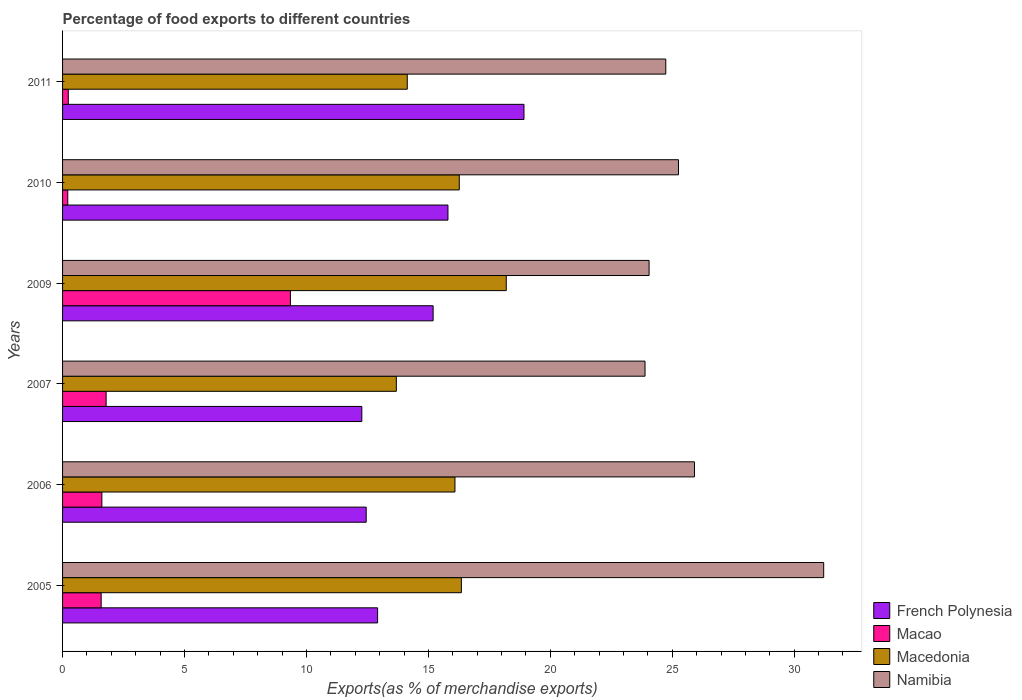Are the number of bars on each tick of the Y-axis equal?
Your response must be concise. Yes. How many bars are there on the 5th tick from the top?
Provide a short and direct response. 4. What is the percentage of exports to different countries in French Polynesia in 2010?
Your answer should be very brief. 15.8. Across all years, what is the maximum percentage of exports to different countries in French Polynesia?
Offer a terse response. 18.92. Across all years, what is the minimum percentage of exports to different countries in Macao?
Give a very brief answer. 0.21. In which year was the percentage of exports to different countries in Macao maximum?
Your response must be concise. 2009. In which year was the percentage of exports to different countries in Namibia minimum?
Make the answer very short. 2007. What is the total percentage of exports to different countries in Macao in the graph?
Your response must be concise. 14.77. What is the difference between the percentage of exports to different countries in Macedonia in 2009 and that in 2011?
Your answer should be very brief. 4.06. What is the difference between the percentage of exports to different countries in Namibia in 2005 and the percentage of exports to different countries in French Polynesia in 2007?
Provide a succinct answer. 18.94. What is the average percentage of exports to different countries in Macedonia per year?
Offer a terse response. 15.79. In the year 2006, what is the difference between the percentage of exports to different countries in Macedonia and percentage of exports to different countries in French Polynesia?
Your answer should be compact. 3.64. In how many years, is the percentage of exports to different countries in Macao greater than 31 %?
Ensure brevity in your answer.  0. What is the ratio of the percentage of exports to different countries in Macao in 2009 to that in 2010?
Give a very brief answer. 43.85. Is the difference between the percentage of exports to different countries in Macedonia in 2007 and 2011 greater than the difference between the percentage of exports to different countries in French Polynesia in 2007 and 2011?
Offer a very short reply. Yes. What is the difference between the highest and the second highest percentage of exports to different countries in Macedonia?
Keep it short and to the point. 1.84. What is the difference between the highest and the lowest percentage of exports to different countries in Macedonia?
Make the answer very short. 4.51. What does the 4th bar from the top in 2005 represents?
Your answer should be compact. French Polynesia. What does the 1st bar from the bottom in 2006 represents?
Offer a very short reply. French Polynesia. How many bars are there?
Your answer should be compact. 24. How many years are there in the graph?
Give a very brief answer. 6. Does the graph contain any zero values?
Keep it short and to the point. No. Does the graph contain grids?
Give a very brief answer. No. Where does the legend appear in the graph?
Your answer should be very brief. Bottom right. What is the title of the graph?
Ensure brevity in your answer.  Percentage of food exports to different countries. Does "Libya" appear as one of the legend labels in the graph?
Your response must be concise. No. What is the label or title of the X-axis?
Your answer should be very brief. Exports(as % of merchandise exports). What is the Exports(as % of merchandise exports) in French Polynesia in 2005?
Ensure brevity in your answer.  12.92. What is the Exports(as % of merchandise exports) in Macao in 2005?
Your answer should be compact. 1.58. What is the Exports(as % of merchandise exports) of Macedonia in 2005?
Your response must be concise. 16.35. What is the Exports(as % of merchandise exports) of Namibia in 2005?
Ensure brevity in your answer.  31.21. What is the Exports(as % of merchandise exports) in French Polynesia in 2006?
Your response must be concise. 12.45. What is the Exports(as % of merchandise exports) in Macao in 2006?
Your response must be concise. 1.61. What is the Exports(as % of merchandise exports) of Macedonia in 2006?
Give a very brief answer. 16.09. What is the Exports(as % of merchandise exports) of Namibia in 2006?
Your answer should be very brief. 25.91. What is the Exports(as % of merchandise exports) of French Polynesia in 2007?
Offer a terse response. 12.27. What is the Exports(as % of merchandise exports) in Macao in 2007?
Provide a short and direct response. 1.79. What is the Exports(as % of merchandise exports) of Macedonia in 2007?
Your answer should be very brief. 13.69. What is the Exports(as % of merchandise exports) in Namibia in 2007?
Keep it short and to the point. 23.88. What is the Exports(as % of merchandise exports) of French Polynesia in 2009?
Give a very brief answer. 15.19. What is the Exports(as % of merchandise exports) of Macao in 2009?
Your answer should be very brief. 9.34. What is the Exports(as % of merchandise exports) in Macedonia in 2009?
Keep it short and to the point. 18.19. What is the Exports(as % of merchandise exports) in Namibia in 2009?
Your answer should be very brief. 24.05. What is the Exports(as % of merchandise exports) in French Polynesia in 2010?
Provide a short and direct response. 15.8. What is the Exports(as % of merchandise exports) in Macao in 2010?
Ensure brevity in your answer.  0.21. What is the Exports(as % of merchandise exports) in Macedonia in 2010?
Your response must be concise. 16.27. What is the Exports(as % of merchandise exports) in Namibia in 2010?
Give a very brief answer. 25.25. What is the Exports(as % of merchandise exports) of French Polynesia in 2011?
Your answer should be compact. 18.92. What is the Exports(as % of merchandise exports) in Macao in 2011?
Offer a very short reply. 0.24. What is the Exports(as % of merchandise exports) in Macedonia in 2011?
Ensure brevity in your answer.  14.13. What is the Exports(as % of merchandise exports) of Namibia in 2011?
Your answer should be compact. 24.73. Across all years, what is the maximum Exports(as % of merchandise exports) in French Polynesia?
Offer a very short reply. 18.92. Across all years, what is the maximum Exports(as % of merchandise exports) in Macao?
Your answer should be compact. 9.34. Across all years, what is the maximum Exports(as % of merchandise exports) of Macedonia?
Provide a succinct answer. 18.19. Across all years, what is the maximum Exports(as % of merchandise exports) in Namibia?
Give a very brief answer. 31.21. Across all years, what is the minimum Exports(as % of merchandise exports) in French Polynesia?
Provide a succinct answer. 12.27. Across all years, what is the minimum Exports(as % of merchandise exports) of Macao?
Ensure brevity in your answer.  0.21. Across all years, what is the minimum Exports(as % of merchandise exports) of Macedonia?
Keep it short and to the point. 13.69. Across all years, what is the minimum Exports(as % of merchandise exports) in Namibia?
Your answer should be very brief. 23.88. What is the total Exports(as % of merchandise exports) of French Polynesia in the graph?
Your answer should be compact. 87.55. What is the total Exports(as % of merchandise exports) in Macao in the graph?
Your answer should be very brief. 14.77. What is the total Exports(as % of merchandise exports) of Macedonia in the graph?
Your answer should be compact. 94.72. What is the total Exports(as % of merchandise exports) in Namibia in the graph?
Your response must be concise. 155.04. What is the difference between the Exports(as % of merchandise exports) in French Polynesia in 2005 and that in 2006?
Your answer should be very brief. 0.47. What is the difference between the Exports(as % of merchandise exports) in Macao in 2005 and that in 2006?
Offer a terse response. -0.03. What is the difference between the Exports(as % of merchandise exports) in Macedonia in 2005 and that in 2006?
Your response must be concise. 0.26. What is the difference between the Exports(as % of merchandise exports) of Namibia in 2005 and that in 2006?
Offer a very short reply. 5.3. What is the difference between the Exports(as % of merchandise exports) in French Polynesia in 2005 and that in 2007?
Provide a short and direct response. 0.65. What is the difference between the Exports(as % of merchandise exports) in Macao in 2005 and that in 2007?
Make the answer very short. -0.2. What is the difference between the Exports(as % of merchandise exports) in Macedonia in 2005 and that in 2007?
Your answer should be compact. 2.67. What is the difference between the Exports(as % of merchandise exports) in Namibia in 2005 and that in 2007?
Your answer should be compact. 7.33. What is the difference between the Exports(as % of merchandise exports) in French Polynesia in 2005 and that in 2009?
Your answer should be compact. -2.28. What is the difference between the Exports(as % of merchandise exports) in Macao in 2005 and that in 2009?
Provide a short and direct response. -7.76. What is the difference between the Exports(as % of merchandise exports) in Macedonia in 2005 and that in 2009?
Keep it short and to the point. -1.84. What is the difference between the Exports(as % of merchandise exports) in Namibia in 2005 and that in 2009?
Offer a very short reply. 7.16. What is the difference between the Exports(as % of merchandise exports) of French Polynesia in 2005 and that in 2010?
Make the answer very short. -2.88. What is the difference between the Exports(as % of merchandise exports) in Macao in 2005 and that in 2010?
Your answer should be compact. 1.37. What is the difference between the Exports(as % of merchandise exports) of Macedonia in 2005 and that in 2010?
Keep it short and to the point. 0.09. What is the difference between the Exports(as % of merchandise exports) in Namibia in 2005 and that in 2010?
Your response must be concise. 5.95. What is the difference between the Exports(as % of merchandise exports) in French Polynesia in 2005 and that in 2011?
Offer a very short reply. -6. What is the difference between the Exports(as % of merchandise exports) in Macao in 2005 and that in 2011?
Your answer should be very brief. 1.35. What is the difference between the Exports(as % of merchandise exports) of Macedonia in 2005 and that in 2011?
Your answer should be compact. 2.22. What is the difference between the Exports(as % of merchandise exports) in Namibia in 2005 and that in 2011?
Make the answer very short. 6.47. What is the difference between the Exports(as % of merchandise exports) in French Polynesia in 2006 and that in 2007?
Your answer should be very brief. 0.18. What is the difference between the Exports(as % of merchandise exports) of Macao in 2006 and that in 2007?
Your response must be concise. -0.17. What is the difference between the Exports(as % of merchandise exports) of Macedonia in 2006 and that in 2007?
Provide a short and direct response. 2.4. What is the difference between the Exports(as % of merchandise exports) of Namibia in 2006 and that in 2007?
Offer a very short reply. 2.03. What is the difference between the Exports(as % of merchandise exports) in French Polynesia in 2006 and that in 2009?
Make the answer very short. -2.75. What is the difference between the Exports(as % of merchandise exports) of Macao in 2006 and that in 2009?
Give a very brief answer. -7.73. What is the difference between the Exports(as % of merchandise exports) of Macedonia in 2006 and that in 2009?
Make the answer very short. -2.1. What is the difference between the Exports(as % of merchandise exports) of Namibia in 2006 and that in 2009?
Provide a short and direct response. 1.86. What is the difference between the Exports(as % of merchandise exports) in French Polynesia in 2006 and that in 2010?
Keep it short and to the point. -3.35. What is the difference between the Exports(as % of merchandise exports) in Macao in 2006 and that in 2010?
Keep it short and to the point. 1.4. What is the difference between the Exports(as % of merchandise exports) in Macedonia in 2006 and that in 2010?
Make the answer very short. -0.18. What is the difference between the Exports(as % of merchandise exports) in Namibia in 2006 and that in 2010?
Ensure brevity in your answer.  0.66. What is the difference between the Exports(as % of merchandise exports) of French Polynesia in 2006 and that in 2011?
Offer a terse response. -6.47. What is the difference between the Exports(as % of merchandise exports) in Macao in 2006 and that in 2011?
Provide a succinct answer. 1.38. What is the difference between the Exports(as % of merchandise exports) of Macedonia in 2006 and that in 2011?
Make the answer very short. 1.96. What is the difference between the Exports(as % of merchandise exports) of Namibia in 2006 and that in 2011?
Your response must be concise. 1.18. What is the difference between the Exports(as % of merchandise exports) in French Polynesia in 2007 and that in 2009?
Ensure brevity in your answer.  -2.92. What is the difference between the Exports(as % of merchandise exports) in Macao in 2007 and that in 2009?
Provide a short and direct response. -7.56. What is the difference between the Exports(as % of merchandise exports) of Macedonia in 2007 and that in 2009?
Provide a short and direct response. -4.51. What is the difference between the Exports(as % of merchandise exports) in Namibia in 2007 and that in 2009?
Your answer should be compact. -0.17. What is the difference between the Exports(as % of merchandise exports) in French Polynesia in 2007 and that in 2010?
Keep it short and to the point. -3.53. What is the difference between the Exports(as % of merchandise exports) in Macao in 2007 and that in 2010?
Make the answer very short. 1.57. What is the difference between the Exports(as % of merchandise exports) of Macedonia in 2007 and that in 2010?
Your answer should be compact. -2.58. What is the difference between the Exports(as % of merchandise exports) in Namibia in 2007 and that in 2010?
Keep it short and to the point. -1.37. What is the difference between the Exports(as % of merchandise exports) of French Polynesia in 2007 and that in 2011?
Your response must be concise. -6.65. What is the difference between the Exports(as % of merchandise exports) in Macao in 2007 and that in 2011?
Your answer should be very brief. 1.55. What is the difference between the Exports(as % of merchandise exports) of Macedonia in 2007 and that in 2011?
Provide a succinct answer. -0.45. What is the difference between the Exports(as % of merchandise exports) in Namibia in 2007 and that in 2011?
Keep it short and to the point. -0.85. What is the difference between the Exports(as % of merchandise exports) of French Polynesia in 2009 and that in 2010?
Keep it short and to the point. -0.61. What is the difference between the Exports(as % of merchandise exports) of Macao in 2009 and that in 2010?
Your answer should be compact. 9.13. What is the difference between the Exports(as % of merchandise exports) in Macedonia in 2009 and that in 2010?
Provide a short and direct response. 1.93. What is the difference between the Exports(as % of merchandise exports) in Namibia in 2009 and that in 2010?
Give a very brief answer. -1.2. What is the difference between the Exports(as % of merchandise exports) of French Polynesia in 2009 and that in 2011?
Keep it short and to the point. -3.73. What is the difference between the Exports(as % of merchandise exports) of Macao in 2009 and that in 2011?
Your answer should be very brief. 9.11. What is the difference between the Exports(as % of merchandise exports) of Macedonia in 2009 and that in 2011?
Give a very brief answer. 4.06. What is the difference between the Exports(as % of merchandise exports) in Namibia in 2009 and that in 2011?
Your answer should be compact. -0.68. What is the difference between the Exports(as % of merchandise exports) of French Polynesia in 2010 and that in 2011?
Make the answer very short. -3.12. What is the difference between the Exports(as % of merchandise exports) of Macao in 2010 and that in 2011?
Your answer should be very brief. -0.02. What is the difference between the Exports(as % of merchandise exports) of Macedonia in 2010 and that in 2011?
Keep it short and to the point. 2.13. What is the difference between the Exports(as % of merchandise exports) of Namibia in 2010 and that in 2011?
Offer a very short reply. 0.52. What is the difference between the Exports(as % of merchandise exports) in French Polynesia in 2005 and the Exports(as % of merchandise exports) in Macao in 2006?
Provide a succinct answer. 11.31. What is the difference between the Exports(as % of merchandise exports) of French Polynesia in 2005 and the Exports(as % of merchandise exports) of Macedonia in 2006?
Make the answer very short. -3.17. What is the difference between the Exports(as % of merchandise exports) in French Polynesia in 2005 and the Exports(as % of merchandise exports) in Namibia in 2006?
Provide a succinct answer. -12.99. What is the difference between the Exports(as % of merchandise exports) of Macao in 2005 and the Exports(as % of merchandise exports) of Macedonia in 2006?
Give a very brief answer. -14.51. What is the difference between the Exports(as % of merchandise exports) of Macao in 2005 and the Exports(as % of merchandise exports) of Namibia in 2006?
Offer a terse response. -24.33. What is the difference between the Exports(as % of merchandise exports) of Macedonia in 2005 and the Exports(as % of merchandise exports) of Namibia in 2006?
Your response must be concise. -9.56. What is the difference between the Exports(as % of merchandise exports) in French Polynesia in 2005 and the Exports(as % of merchandise exports) in Macao in 2007?
Make the answer very short. 11.13. What is the difference between the Exports(as % of merchandise exports) in French Polynesia in 2005 and the Exports(as % of merchandise exports) in Macedonia in 2007?
Your answer should be very brief. -0.77. What is the difference between the Exports(as % of merchandise exports) of French Polynesia in 2005 and the Exports(as % of merchandise exports) of Namibia in 2007?
Provide a succinct answer. -10.97. What is the difference between the Exports(as % of merchandise exports) of Macao in 2005 and the Exports(as % of merchandise exports) of Macedonia in 2007?
Offer a very short reply. -12.1. What is the difference between the Exports(as % of merchandise exports) of Macao in 2005 and the Exports(as % of merchandise exports) of Namibia in 2007?
Offer a very short reply. -22.3. What is the difference between the Exports(as % of merchandise exports) of Macedonia in 2005 and the Exports(as % of merchandise exports) of Namibia in 2007?
Your answer should be compact. -7.53. What is the difference between the Exports(as % of merchandise exports) of French Polynesia in 2005 and the Exports(as % of merchandise exports) of Macao in 2009?
Make the answer very short. 3.57. What is the difference between the Exports(as % of merchandise exports) of French Polynesia in 2005 and the Exports(as % of merchandise exports) of Macedonia in 2009?
Make the answer very short. -5.28. What is the difference between the Exports(as % of merchandise exports) of French Polynesia in 2005 and the Exports(as % of merchandise exports) of Namibia in 2009?
Ensure brevity in your answer.  -11.13. What is the difference between the Exports(as % of merchandise exports) of Macao in 2005 and the Exports(as % of merchandise exports) of Macedonia in 2009?
Your response must be concise. -16.61. What is the difference between the Exports(as % of merchandise exports) in Macao in 2005 and the Exports(as % of merchandise exports) in Namibia in 2009?
Provide a succinct answer. -22.47. What is the difference between the Exports(as % of merchandise exports) in Macedonia in 2005 and the Exports(as % of merchandise exports) in Namibia in 2009?
Ensure brevity in your answer.  -7.7. What is the difference between the Exports(as % of merchandise exports) in French Polynesia in 2005 and the Exports(as % of merchandise exports) in Macao in 2010?
Your answer should be very brief. 12.7. What is the difference between the Exports(as % of merchandise exports) in French Polynesia in 2005 and the Exports(as % of merchandise exports) in Macedonia in 2010?
Provide a short and direct response. -3.35. What is the difference between the Exports(as % of merchandise exports) of French Polynesia in 2005 and the Exports(as % of merchandise exports) of Namibia in 2010?
Your response must be concise. -12.34. What is the difference between the Exports(as % of merchandise exports) of Macao in 2005 and the Exports(as % of merchandise exports) of Macedonia in 2010?
Ensure brevity in your answer.  -14.68. What is the difference between the Exports(as % of merchandise exports) in Macao in 2005 and the Exports(as % of merchandise exports) in Namibia in 2010?
Provide a succinct answer. -23.67. What is the difference between the Exports(as % of merchandise exports) in Macedonia in 2005 and the Exports(as % of merchandise exports) in Namibia in 2010?
Keep it short and to the point. -8.9. What is the difference between the Exports(as % of merchandise exports) of French Polynesia in 2005 and the Exports(as % of merchandise exports) of Macao in 2011?
Your response must be concise. 12.68. What is the difference between the Exports(as % of merchandise exports) in French Polynesia in 2005 and the Exports(as % of merchandise exports) in Macedonia in 2011?
Provide a short and direct response. -1.22. What is the difference between the Exports(as % of merchandise exports) in French Polynesia in 2005 and the Exports(as % of merchandise exports) in Namibia in 2011?
Keep it short and to the point. -11.82. What is the difference between the Exports(as % of merchandise exports) of Macao in 2005 and the Exports(as % of merchandise exports) of Macedonia in 2011?
Keep it short and to the point. -12.55. What is the difference between the Exports(as % of merchandise exports) in Macao in 2005 and the Exports(as % of merchandise exports) in Namibia in 2011?
Make the answer very short. -23.15. What is the difference between the Exports(as % of merchandise exports) of Macedonia in 2005 and the Exports(as % of merchandise exports) of Namibia in 2011?
Provide a succinct answer. -8.38. What is the difference between the Exports(as % of merchandise exports) in French Polynesia in 2006 and the Exports(as % of merchandise exports) in Macao in 2007?
Give a very brief answer. 10.66. What is the difference between the Exports(as % of merchandise exports) in French Polynesia in 2006 and the Exports(as % of merchandise exports) in Macedonia in 2007?
Your response must be concise. -1.24. What is the difference between the Exports(as % of merchandise exports) in French Polynesia in 2006 and the Exports(as % of merchandise exports) in Namibia in 2007?
Your answer should be very brief. -11.43. What is the difference between the Exports(as % of merchandise exports) of Macao in 2006 and the Exports(as % of merchandise exports) of Macedonia in 2007?
Ensure brevity in your answer.  -12.07. What is the difference between the Exports(as % of merchandise exports) of Macao in 2006 and the Exports(as % of merchandise exports) of Namibia in 2007?
Give a very brief answer. -22.27. What is the difference between the Exports(as % of merchandise exports) in Macedonia in 2006 and the Exports(as % of merchandise exports) in Namibia in 2007?
Offer a terse response. -7.79. What is the difference between the Exports(as % of merchandise exports) in French Polynesia in 2006 and the Exports(as % of merchandise exports) in Macao in 2009?
Make the answer very short. 3.11. What is the difference between the Exports(as % of merchandise exports) in French Polynesia in 2006 and the Exports(as % of merchandise exports) in Macedonia in 2009?
Offer a very short reply. -5.74. What is the difference between the Exports(as % of merchandise exports) of French Polynesia in 2006 and the Exports(as % of merchandise exports) of Namibia in 2009?
Ensure brevity in your answer.  -11.6. What is the difference between the Exports(as % of merchandise exports) in Macao in 2006 and the Exports(as % of merchandise exports) in Macedonia in 2009?
Keep it short and to the point. -16.58. What is the difference between the Exports(as % of merchandise exports) in Macao in 2006 and the Exports(as % of merchandise exports) in Namibia in 2009?
Ensure brevity in your answer.  -22.44. What is the difference between the Exports(as % of merchandise exports) in Macedonia in 2006 and the Exports(as % of merchandise exports) in Namibia in 2009?
Give a very brief answer. -7.96. What is the difference between the Exports(as % of merchandise exports) in French Polynesia in 2006 and the Exports(as % of merchandise exports) in Macao in 2010?
Provide a short and direct response. 12.24. What is the difference between the Exports(as % of merchandise exports) of French Polynesia in 2006 and the Exports(as % of merchandise exports) of Macedonia in 2010?
Give a very brief answer. -3.82. What is the difference between the Exports(as % of merchandise exports) in French Polynesia in 2006 and the Exports(as % of merchandise exports) in Namibia in 2010?
Provide a short and direct response. -12.81. What is the difference between the Exports(as % of merchandise exports) of Macao in 2006 and the Exports(as % of merchandise exports) of Macedonia in 2010?
Provide a succinct answer. -14.65. What is the difference between the Exports(as % of merchandise exports) of Macao in 2006 and the Exports(as % of merchandise exports) of Namibia in 2010?
Make the answer very short. -23.64. What is the difference between the Exports(as % of merchandise exports) of Macedonia in 2006 and the Exports(as % of merchandise exports) of Namibia in 2010?
Provide a short and direct response. -9.17. What is the difference between the Exports(as % of merchandise exports) in French Polynesia in 2006 and the Exports(as % of merchandise exports) in Macao in 2011?
Keep it short and to the point. 12.21. What is the difference between the Exports(as % of merchandise exports) of French Polynesia in 2006 and the Exports(as % of merchandise exports) of Macedonia in 2011?
Provide a succinct answer. -1.68. What is the difference between the Exports(as % of merchandise exports) in French Polynesia in 2006 and the Exports(as % of merchandise exports) in Namibia in 2011?
Your answer should be compact. -12.28. What is the difference between the Exports(as % of merchandise exports) in Macao in 2006 and the Exports(as % of merchandise exports) in Macedonia in 2011?
Give a very brief answer. -12.52. What is the difference between the Exports(as % of merchandise exports) in Macao in 2006 and the Exports(as % of merchandise exports) in Namibia in 2011?
Your answer should be very brief. -23.12. What is the difference between the Exports(as % of merchandise exports) of Macedonia in 2006 and the Exports(as % of merchandise exports) of Namibia in 2011?
Make the answer very short. -8.64. What is the difference between the Exports(as % of merchandise exports) of French Polynesia in 2007 and the Exports(as % of merchandise exports) of Macao in 2009?
Offer a terse response. 2.93. What is the difference between the Exports(as % of merchandise exports) of French Polynesia in 2007 and the Exports(as % of merchandise exports) of Macedonia in 2009?
Offer a very short reply. -5.92. What is the difference between the Exports(as % of merchandise exports) of French Polynesia in 2007 and the Exports(as % of merchandise exports) of Namibia in 2009?
Offer a very short reply. -11.78. What is the difference between the Exports(as % of merchandise exports) of Macao in 2007 and the Exports(as % of merchandise exports) of Macedonia in 2009?
Your answer should be compact. -16.41. What is the difference between the Exports(as % of merchandise exports) of Macao in 2007 and the Exports(as % of merchandise exports) of Namibia in 2009?
Provide a short and direct response. -22.26. What is the difference between the Exports(as % of merchandise exports) in Macedonia in 2007 and the Exports(as % of merchandise exports) in Namibia in 2009?
Your answer should be compact. -10.36. What is the difference between the Exports(as % of merchandise exports) in French Polynesia in 2007 and the Exports(as % of merchandise exports) in Macao in 2010?
Keep it short and to the point. 12.06. What is the difference between the Exports(as % of merchandise exports) of French Polynesia in 2007 and the Exports(as % of merchandise exports) of Macedonia in 2010?
Offer a very short reply. -4. What is the difference between the Exports(as % of merchandise exports) of French Polynesia in 2007 and the Exports(as % of merchandise exports) of Namibia in 2010?
Offer a terse response. -12.98. What is the difference between the Exports(as % of merchandise exports) in Macao in 2007 and the Exports(as % of merchandise exports) in Macedonia in 2010?
Give a very brief answer. -14.48. What is the difference between the Exports(as % of merchandise exports) in Macao in 2007 and the Exports(as % of merchandise exports) in Namibia in 2010?
Your answer should be compact. -23.47. What is the difference between the Exports(as % of merchandise exports) in Macedonia in 2007 and the Exports(as % of merchandise exports) in Namibia in 2010?
Your response must be concise. -11.57. What is the difference between the Exports(as % of merchandise exports) of French Polynesia in 2007 and the Exports(as % of merchandise exports) of Macao in 2011?
Keep it short and to the point. 12.04. What is the difference between the Exports(as % of merchandise exports) of French Polynesia in 2007 and the Exports(as % of merchandise exports) of Macedonia in 2011?
Offer a very short reply. -1.86. What is the difference between the Exports(as % of merchandise exports) in French Polynesia in 2007 and the Exports(as % of merchandise exports) in Namibia in 2011?
Provide a short and direct response. -12.46. What is the difference between the Exports(as % of merchandise exports) of Macao in 2007 and the Exports(as % of merchandise exports) of Macedonia in 2011?
Offer a very short reply. -12.35. What is the difference between the Exports(as % of merchandise exports) in Macao in 2007 and the Exports(as % of merchandise exports) in Namibia in 2011?
Your response must be concise. -22.95. What is the difference between the Exports(as % of merchandise exports) in Macedonia in 2007 and the Exports(as % of merchandise exports) in Namibia in 2011?
Give a very brief answer. -11.05. What is the difference between the Exports(as % of merchandise exports) in French Polynesia in 2009 and the Exports(as % of merchandise exports) in Macao in 2010?
Give a very brief answer. 14.98. What is the difference between the Exports(as % of merchandise exports) of French Polynesia in 2009 and the Exports(as % of merchandise exports) of Macedonia in 2010?
Keep it short and to the point. -1.07. What is the difference between the Exports(as % of merchandise exports) in French Polynesia in 2009 and the Exports(as % of merchandise exports) in Namibia in 2010?
Provide a succinct answer. -10.06. What is the difference between the Exports(as % of merchandise exports) in Macao in 2009 and the Exports(as % of merchandise exports) in Macedonia in 2010?
Ensure brevity in your answer.  -6.92. What is the difference between the Exports(as % of merchandise exports) of Macao in 2009 and the Exports(as % of merchandise exports) of Namibia in 2010?
Provide a succinct answer. -15.91. What is the difference between the Exports(as % of merchandise exports) of Macedonia in 2009 and the Exports(as % of merchandise exports) of Namibia in 2010?
Your answer should be compact. -7.06. What is the difference between the Exports(as % of merchandise exports) of French Polynesia in 2009 and the Exports(as % of merchandise exports) of Macao in 2011?
Your answer should be compact. 14.96. What is the difference between the Exports(as % of merchandise exports) in French Polynesia in 2009 and the Exports(as % of merchandise exports) in Macedonia in 2011?
Provide a succinct answer. 1.06. What is the difference between the Exports(as % of merchandise exports) of French Polynesia in 2009 and the Exports(as % of merchandise exports) of Namibia in 2011?
Your answer should be compact. -9.54. What is the difference between the Exports(as % of merchandise exports) in Macao in 2009 and the Exports(as % of merchandise exports) in Macedonia in 2011?
Keep it short and to the point. -4.79. What is the difference between the Exports(as % of merchandise exports) of Macao in 2009 and the Exports(as % of merchandise exports) of Namibia in 2011?
Your answer should be very brief. -15.39. What is the difference between the Exports(as % of merchandise exports) in Macedonia in 2009 and the Exports(as % of merchandise exports) in Namibia in 2011?
Provide a succinct answer. -6.54. What is the difference between the Exports(as % of merchandise exports) of French Polynesia in 2010 and the Exports(as % of merchandise exports) of Macao in 2011?
Give a very brief answer. 15.57. What is the difference between the Exports(as % of merchandise exports) in French Polynesia in 2010 and the Exports(as % of merchandise exports) in Macedonia in 2011?
Give a very brief answer. 1.67. What is the difference between the Exports(as % of merchandise exports) of French Polynesia in 2010 and the Exports(as % of merchandise exports) of Namibia in 2011?
Offer a terse response. -8.93. What is the difference between the Exports(as % of merchandise exports) in Macao in 2010 and the Exports(as % of merchandise exports) in Macedonia in 2011?
Your answer should be very brief. -13.92. What is the difference between the Exports(as % of merchandise exports) of Macao in 2010 and the Exports(as % of merchandise exports) of Namibia in 2011?
Offer a very short reply. -24.52. What is the difference between the Exports(as % of merchandise exports) of Macedonia in 2010 and the Exports(as % of merchandise exports) of Namibia in 2011?
Your answer should be very brief. -8.47. What is the average Exports(as % of merchandise exports) of French Polynesia per year?
Your response must be concise. 14.59. What is the average Exports(as % of merchandise exports) of Macao per year?
Your answer should be compact. 2.46. What is the average Exports(as % of merchandise exports) of Macedonia per year?
Give a very brief answer. 15.79. What is the average Exports(as % of merchandise exports) in Namibia per year?
Your answer should be compact. 25.84. In the year 2005, what is the difference between the Exports(as % of merchandise exports) of French Polynesia and Exports(as % of merchandise exports) of Macao?
Provide a succinct answer. 11.33. In the year 2005, what is the difference between the Exports(as % of merchandise exports) in French Polynesia and Exports(as % of merchandise exports) in Macedonia?
Provide a succinct answer. -3.44. In the year 2005, what is the difference between the Exports(as % of merchandise exports) of French Polynesia and Exports(as % of merchandise exports) of Namibia?
Your response must be concise. -18.29. In the year 2005, what is the difference between the Exports(as % of merchandise exports) of Macao and Exports(as % of merchandise exports) of Macedonia?
Keep it short and to the point. -14.77. In the year 2005, what is the difference between the Exports(as % of merchandise exports) in Macao and Exports(as % of merchandise exports) in Namibia?
Provide a succinct answer. -29.63. In the year 2005, what is the difference between the Exports(as % of merchandise exports) in Macedonia and Exports(as % of merchandise exports) in Namibia?
Ensure brevity in your answer.  -14.86. In the year 2006, what is the difference between the Exports(as % of merchandise exports) in French Polynesia and Exports(as % of merchandise exports) in Macao?
Your response must be concise. 10.84. In the year 2006, what is the difference between the Exports(as % of merchandise exports) in French Polynesia and Exports(as % of merchandise exports) in Macedonia?
Make the answer very short. -3.64. In the year 2006, what is the difference between the Exports(as % of merchandise exports) in French Polynesia and Exports(as % of merchandise exports) in Namibia?
Your answer should be compact. -13.46. In the year 2006, what is the difference between the Exports(as % of merchandise exports) in Macao and Exports(as % of merchandise exports) in Macedonia?
Your response must be concise. -14.48. In the year 2006, what is the difference between the Exports(as % of merchandise exports) in Macao and Exports(as % of merchandise exports) in Namibia?
Provide a succinct answer. -24.3. In the year 2006, what is the difference between the Exports(as % of merchandise exports) of Macedonia and Exports(as % of merchandise exports) of Namibia?
Offer a terse response. -9.82. In the year 2007, what is the difference between the Exports(as % of merchandise exports) of French Polynesia and Exports(as % of merchandise exports) of Macao?
Give a very brief answer. 10.48. In the year 2007, what is the difference between the Exports(as % of merchandise exports) of French Polynesia and Exports(as % of merchandise exports) of Macedonia?
Keep it short and to the point. -1.41. In the year 2007, what is the difference between the Exports(as % of merchandise exports) of French Polynesia and Exports(as % of merchandise exports) of Namibia?
Keep it short and to the point. -11.61. In the year 2007, what is the difference between the Exports(as % of merchandise exports) in Macao and Exports(as % of merchandise exports) in Macedonia?
Offer a very short reply. -11.9. In the year 2007, what is the difference between the Exports(as % of merchandise exports) of Macao and Exports(as % of merchandise exports) of Namibia?
Give a very brief answer. -22.1. In the year 2007, what is the difference between the Exports(as % of merchandise exports) of Macedonia and Exports(as % of merchandise exports) of Namibia?
Keep it short and to the point. -10.2. In the year 2009, what is the difference between the Exports(as % of merchandise exports) of French Polynesia and Exports(as % of merchandise exports) of Macao?
Keep it short and to the point. 5.85. In the year 2009, what is the difference between the Exports(as % of merchandise exports) of French Polynesia and Exports(as % of merchandise exports) of Macedonia?
Provide a short and direct response. -3. In the year 2009, what is the difference between the Exports(as % of merchandise exports) of French Polynesia and Exports(as % of merchandise exports) of Namibia?
Your answer should be compact. -8.86. In the year 2009, what is the difference between the Exports(as % of merchandise exports) in Macao and Exports(as % of merchandise exports) in Macedonia?
Give a very brief answer. -8.85. In the year 2009, what is the difference between the Exports(as % of merchandise exports) of Macao and Exports(as % of merchandise exports) of Namibia?
Provide a short and direct response. -14.71. In the year 2009, what is the difference between the Exports(as % of merchandise exports) of Macedonia and Exports(as % of merchandise exports) of Namibia?
Your response must be concise. -5.86. In the year 2010, what is the difference between the Exports(as % of merchandise exports) of French Polynesia and Exports(as % of merchandise exports) of Macao?
Keep it short and to the point. 15.59. In the year 2010, what is the difference between the Exports(as % of merchandise exports) of French Polynesia and Exports(as % of merchandise exports) of Macedonia?
Provide a short and direct response. -0.46. In the year 2010, what is the difference between the Exports(as % of merchandise exports) in French Polynesia and Exports(as % of merchandise exports) in Namibia?
Give a very brief answer. -9.45. In the year 2010, what is the difference between the Exports(as % of merchandise exports) of Macao and Exports(as % of merchandise exports) of Macedonia?
Provide a short and direct response. -16.05. In the year 2010, what is the difference between the Exports(as % of merchandise exports) of Macao and Exports(as % of merchandise exports) of Namibia?
Ensure brevity in your answer.  -25.04. In the year 2010, what is the difference between the Exports(as % of merchandise exports) in Macedonia and Exports(as % of merchandise exports) in Namibia?
Provide a short and direct response. -8.99. In the year 2011, what is the difference between the Exports(as % of merchandise exports) of French Polynesia and Exports(as % of merchandise exports) of Macao?
Your answer should be very brief. 18.68. In the year 2011, what is the difference between the Exports(as % of merchandise exports) in French Polynesia and Exports(as % of merchandise exports) in Macedonia?
Provide a succinct answer. 4.79. In the year 2011, what is the difference between the Exports(as % of merchandise exports) in French Polynesia and Exports(as % of merchandise exports) in Namibia?
Keep it short and to the point. -5.81. In the year 2011, what is the difference between the Exports(as % of merchandise exports) of Macao and Exports(as % of merchandise exports) of Macedonia?
Provide a short and direct response. -13.9. In the year 2011, what is the difference between the Exports(as % of merchandise exports) of Macao and Exports(as % of merchandise exports) of Namibia?
Offer a terse response. -24.5. In the year 2011, what is the difference between the Exports(as % of merchandise exports) in Macedonia and Exports(as % of merchandise exports) in Namibia?
Offer a terse response. -10.6. What is the ratio of the Exports(as % of merchandise exports) in French Polynesia in 2005 to that in 2006?
Your answer should be very brief. 1.04. What is the ratio of the Exports(as % of merchandise exports) of Macao in 2005 to that in 2006?
Your response must be concise. 0.98. What is the ratio of the Exports(as % of merchandise exports) in Macedonia in 2005 to that in 2006?
Give a very brief answer. 1.02. What is the ratio of the Exports(as % of merchandise exports) of Namibia in 2005 to that in 2006?
Offer a terse response. 1.2. What is the ratio of the Exports(as % of merchandise exports) of French Polynesia in 2005 to that in 2007?
Offer a terse response. 1.05. What is the ratio of the Exports(as % of merchandise exports) of Macao in 2005 to that in 2007?
Offer a very short reply. 0.89. What is the ratio of the Exports(as % of merchandise exports) of Macedonia in 2005 to that in 2007?
Provide a succinct answer. 1.19. What is the ratio of the Exports(as % of merchandise exports) in Namibia in 2005 to that in 2007?
Keep it short and to the point. 1.31. What is the ratio of the Exports(as % of merchandise exports) of French Polynesia in 2005 to that in 2009?
Your answer should be compact. 0.85. What is the ratio of the Exports(as % of merchandise exports) of Macao in 2005 to that in 2009?
Make the answer very short. 0.17. What is the ratio of the Exports(as % of merchandise exports) of Macedonia in 2005 to that in 2009?
Keep it short and to the point. 0.9. What is the ratio of the Exports(as % of merchandise exports) in Namibia in 2005 to that in 2009?
Your response must be concise. 1.3. What is the ratio of the Exports(as % of merchandise exports) in French Polynesia in 2005 to that in 2010?
Offer a very short reply. 0.82. What is the ratio of the Exports(as % of merchandise exports) in Macao in 2005 to that in 2010?
Keep it short and to the point. 7.43. What is the ratio of the Exports(as % of merchandise exports) of Namibia in 2005 to that in 2010?
Give a very brief answer. 1.24. What is the ratio of the Exports(as % of merchandise exports) of French Polynesia in 2005 to that in 2011?
Ensure brevity in your answer.  0.68. What is the ratio of the Exports(as % of merchandise exports) in Macao in 2005 to that in 2011?
Provide a short and direct response. 6.73. What is the ratio of the Exports(as % of merchandise exports) in Macedonia in 2005 to that in 2011?
Keep it short and to the point. 1.16. What is the ratio of the Exports(as % of merchandise exports) of Namibia in 2005 to that in 2011?
Provide a succinct answer. 1.26. What is the ratio of the Exports(as % of merchandise exports) of French Polynesia in 2006 to that in 2007?
Ensure brevity in your answer.  1.01. What is the ratio of the Exports(as % of merchandise exports) of Macao in 2006 to that in 2007?
Ensure brevity in your answer.  0.9. What is the ratio of the Exports(as % of merchandise exports) of Macedonia in 2006 to that in 2007?
Make the answer very short. 1.18. What is the ratio of the Exports(as % of merchandise exports) of Namibia in 2006 to that in 2007?
Keep it short and to the point. 1.08. What is the ratio of the Exports(as % of merchandise exports) in French Polynesia in 2006 to that in 2009?
Your response must be concise. 0.82. What is the ratio of the Exports(as % of merchandise exports) of Macao in 2006 to that in 2009?
Provide a short and direct response. 0.17. What is the ratio of the Exports(as % of merchandise exports) in Macedonia in 2006 to that in 2009?
Give a very brief answer. 0.88. What is the ratio of the Exports(as % of merchandise exports) in Namibia in 2006 to that in 2009?
Offer a very short reply. 1.08. What is the ratio of the Exports(as % of merchandise exports) of French Polynesia in 2006 to that in 2010?
Give a very brief answer. 0.79. What is the ratio of the Exports(as % of merchandise exports) of Macao in 2006 to that in 2010?
Ensure brevity in your answer.  7.56. What is the ratio of the Exports(as % of merchandise exports) of Macedonia in 2006 to that in 2010?
Offer a very short reply. 0.99. What is the ratio of the Exports(as % of merchandise exports) of French Polynesia in 2006 to that in 2011?
Keep it short and to the point. 0.66. What is the ratio of the Exports(as % of merchandise exports) in Macao in 2006 to that in 2011?
Your answer should be compact. 6.86. What is the ratio of the Exports(as % of merchandise exports) of Macedonia in 2006 to that in 2011?
Provide a short and direct response. 1.14. What is the ratio of the Exports(as % of merchandise exports) in Namibia in 2006 to that in 2011?
Your response must be concise. 1.05. What is the ratio of the Exports(as % of merchandise exports) in French Polynesia in 2007 to that in 2009?
Keep it short and to the point. 0.81. What is the ratio of the Exports(as % of merchandise exports) in Macao in 2007 to that in 2009?
Your answer should be very brief. 0.19. What is the ratio of the Exports(as % of merchandise exports) in Macedonia in 2007 to that in 2009?
Offer a terse response. 0.75. What is the ratio of the Exports(as % of merchandise exports) of French Polynesia in 2007 to that in 2010?
Provide a short and direct response. 0.78. What is the ratio of the Exports(as % of merchandise exports) of Macao in 2007 to that in 2010?
Make the answer very short. 8.38. What is the ratio of the Exports(as % of merchandise exports) in Macedonia in 2007 to that in 2010?
Provide a short and direct response. 0.84. What is the ratio of the Exports(as % of merchandise exports) in Namibia in 2007 to that in 2010?
Offer a very short reply. 0.95. What is the ratio of the Exports(as % of merchandise exports) of French Polynesia in 2007 to that in 2011?
Offer a very short reply. 0.65. What is the ratio of the Exports(as % of merchandise exports) in Macao in 2007 to that in 2011?
Provide a succinct answer. 7.6. What is the ratio of the Exports(as % of merchandise exports) in Macedonia in 2007 to that in 2011?
Your answer should be very brief. 0.97. What is the ratio of the Exports(as % of merchandise exports) of Namibia in 2007 to that in 2011?
Your answer should be very brief. 0.97. What is the ratio of the Exports(as % of merchandise exports) of French Polynesia in 2009 to that in 2010?
Offer a terse response. 0.96. What is the ratio of the Exports(as % of merchandise exports) in Macao in 2009 to that in 2010?
Provide a succinct answer. 43.85. What is the ratio of the Exports(as % of merchandise exports) in Macedonia in 2009 to that in 2010?
Keep it short and to the point. 1.12. What is the ratio of the Exports(as % of merchandise exports) of Namibia in 2009 to that in 2010?
Provide a short and direct response. 0.95. What is the ratio of the Exports(as % of merchandise exports) in French Polynesia in 2009 to that in 2011?
Offer a terse response. 0.8. What is the ratio of the Exports(as % of merchandise exports) of Macao in 2009 to that in 2011?
Your answer should be compact. 39.74. What is the ratio of the Exports(as % of merchandise exports) of Macedonia in 2009 to that in 2011?
Your answer should be very brief. 1.29. What is the ratio of the Exports(as % of merchandise exports) in Namibia in 2009 to that in 2011?
Ensure brevity in your answer.  0.97. What is the ratio of the Exports(as % of merchandise exports) of French Polynesia in 2010 to that in 2011?
Keep it short and to the point. 0.84. What is the ratio of the Exports(as % of merchandise exports) of Macao in 2010 to that in 2011?
Ensure brevity in your answer.  0.91. What is the ratio of the Exports(as % of merchandise exports) of Macedonia in 2010 to that in 2011?
Your response must be concise. 1.15. What is the ratio of the Exports(as % of merchandise exports) in Namibia in 2010 to that in 2011?
Offer a terse response. 1.02. What is the difference between the highest and the second highest Exports(as % of merchandise exports) of French Polynesia?
Your answer should be very brief. 3.12. What is the difference between the highest and the second highest Exports(as % of merchandise exports) of Macao?
Keep it short and to the point. 7.56. What is the difference between the highest and the second highest Exports(as % of merchandise exports) in Macedonia?
Your answer should be compact. 1.84. What is the difference between the highest and the second highest Exports(as % of merchandise exports) in Namibia?
Your answer should be very brief. 5.3. What is the difference between the highest and the lowest Exports(as % of merchandise exports) in French Polynesia?
Your answer should be very brief. 6.65. What is the difference between the highest and the lowest Exports(as % of merchandise exports) of Macao?
Offer a very short reply. 9.13. What is the difference between the highest and the lowest Exports(as % of merchandise exports) in Macedonia?
Provide a short and direct response. 4.51. What is the difference between the highest and the lowest Exports(as % of merchandise exports) of Namibia?
Ensure brevity in your answer.  7.33. 